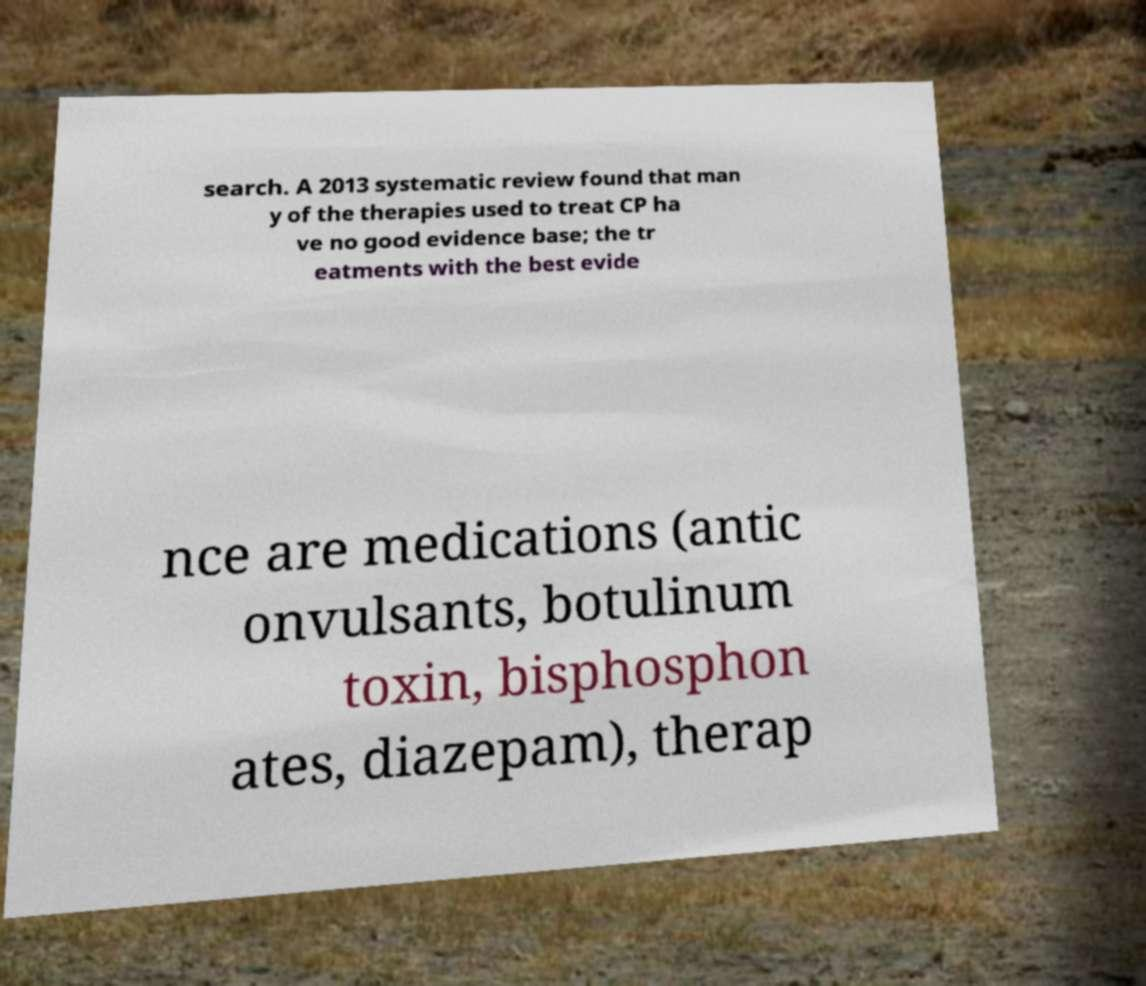Can you accurately transcribe the text from the provided image for me? search. A 2013 systematic review found that man y of the therapies used to treat CP ha ve no good evidence base; the tr eatments with the best evide nce are medications (antic onvulsants, botulinum toxin, bisphosphon ates, diazepam), therap 